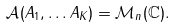<formula> <loc_0><loc_0><loc_500><loc_500>\mathcal { A } ( A _ { 1 } , \dots A _ { K } ) = \mathcal { M } _ { n } ( \mathbb { C } ) .</formula> 